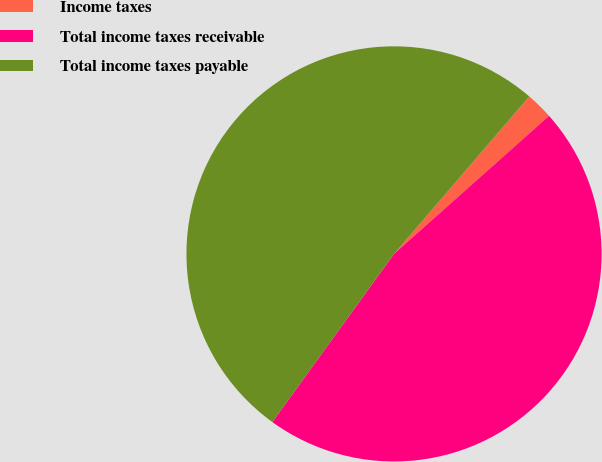<chart> <loc_0><loc_0><loc_500><loc_500><pie_chart><fcel>Income taxes<fcel>Total income taxes receivable<fcel>Total income taxes payable<nl><fcel>2.12%<fcel>46.55%<fcel>51.33%<nl></chart> 